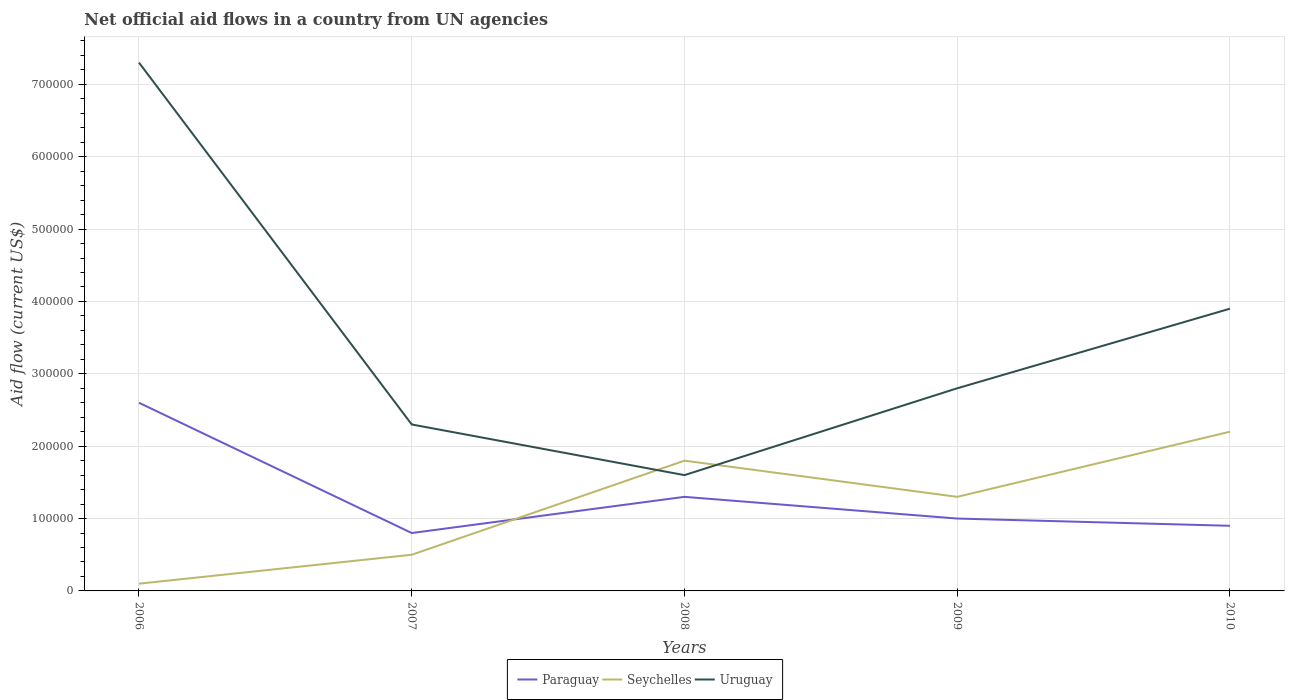Does the line corresponding to Paraguay intersect with the line corresponding to Uruguay?
Offer a very short reply. No. Across all years, what is the maximum net official aid flow in Seychelles?
Ensure brevity in your answer.  10000. What is the total net official aid flow in Seychelles in the graph?
Your response must be concise. 5.00e+04. What is the difference between the highest and the second highest net official aid flow in Uruguay?
Offer a very short reply. 5.70e+05. What is the difference between the highest and the lowest net official aid flow in Uruguay?
Give a very brief answer. 2. Is the net official aid flow in Paraguay strictly greater than the net official aid flow in Uruguay over the years?
Offer a very short reply. Yes. Are the values on the major ticks of Y-axis written in scientific E-notation?
Offer a terse response. No. What is the title of the graph?
Your answer should be compact. Net official aid flows in a country from UN agencies. What is the label or title of the X-axis?
Ensure brevity in your answer.  Years. What is the label or title of the Y-axis?
Your answer should be very brief. Aid flow (current US$). What is the Aid flow (current US$) in Paraguay in 2006?
Your answer should be very brief. 2.60e+05. What is the Aid flow (current US$) of Uruguay in 2006?
Offer a terse response. 7.30e+05. What is the Aid flow (current US$) in Paraguay in 2007?
Provide a short and direct response. 8.00e+04. What is the Aid flow (current US$) in Uruguay in 2007?
Your answer should be compact. 2.30e+05. What is the Aid flow (current US$) of Uruguay in 2008?
Offer a terse response. 1.60e+05. What is the Aid flow (current US$) in Uruguay in 2009?
Make the answer very short. 2.80e+05. What is the Aid flow (current US$) in Paraguay in 2010?
Your response must be concise. 9.00e+04. What is the Aid flow (current US$) of Uruguay in 2010?
Make the answer very short. 3.90e+05. Across all years, what is the maximum Aid flow (current US$) of Paraguay?
Your answer should be compact. 2.60e+05. Across all years, what is the maximum Aid flow (current US$) of Uruguay?
Provide a succinct answer. 7.30e+05. What is the total Aid flow (current US$) in Paraguay in the graph?
Ensure brevity in your answer.  6.60e+05. What is the total Aid flow (current US$) in Seychelles in the graph?
Give a very brief answer. 5.90e+05. What is the total Aid flow (current US$) in Uruguay in the graph?
Your answer should be compact. 1.79e+06. What is the difference between the Aid flow (current US$) in Paraguay in 2006 and that in 2007?
Provide a short and direct response. 1.80e+05. What is the difference between the Aid flow (current US$) of Seychelles in 2006 and that in 2007?
Give a very brief answer. -4.00e+04. What is the difference between the Aid flow (current US$) of Uruguay in 2006 and that in 2007?
Provide a succinct answer. 5.00e+05. What is the difference between the Aid flow (current US$) in Uruguay in 2006 and that in 2008?
Your response must be concise. 5.70e+05. What is the difference between the Aid flow (current US$) in Seychelles in 2006 and that in 2009?
Your answer should be compact. -1.20e+05. What is the difference between the Aid flow (current US$) of Uruguay in 2006 and that in 2009?
Keep it short and to the point. 4.50e+05. What is the difference between the Aid flow (current US$) of Seychelles in 2006 and that in 2010?
Keep it short and to the point. -2.10e+05. What is the difference between the Aid flow (current US$) of Uruguay in 2006 and that in 2010?
Provide a succinct answer. 3.40e+05. What is the difference between the Aid flow (current US$) in Seychelles in 2007 and that in 2008?
Your answer should be very brief. -1.30e+05. What is the difference between the Aid flow (current US$) in Uruguay in 2007 and that in 2008?
Offer a very short reply. 7.00e+04. What is the difference between the Aid flow (current US$) of Paraguay in 2007 and that in 2009?
Provide a succinct answer. -2.00e+04. What is the difference between the Aid flow (current US$) in Uruguay in 2007 and that in 2009?
Make the answer very short. -5.00e+04. What is the difference between the Aid flow (current US$) of Paraguay in 2007 and that in 2010?
Offer a terse response. -10000. What is the difference between the Aid flow (current US$) in Seychelles in 2008 and that in 2010?
Give a very brief answer. -4.00e+04. What is the difference between the Aid flow (current US$) of Paraguay in 2009 and that in 2010?
Provide a short and direct response. 10000. What is the difference between the Aid flow (current US$) of Seychelles in 2009 and that in 2010?
Ensure brevity in your answer.  -9.00e+04. What is the difference between the Aid flow (current US$) of Paraguay in 2006 and the Aid flow (current US$) of Uruguay in 2007?
Provide a succinct answer. 3.00e+04. What is the difference between the Aid flow (current US$) in Seychelles in 2006 and the Aid flow (current US$) in Uruguay in 2007?
Offer a very short reply. -2.20e+05. What is the difference between the Aid flow (current US$) of Paraguay in 2006 and the Aid flow (current US$) of Seychelles in 2008?
Ensure brevity in your answer.  8.00e+04. What is the difference between the Aid flow (current US$) of Paraguay in 2006 and the Aid flow (current US$) of Uruguay in 2008?
Provide a short and direct response. 1.00e+05. What is the difference between the Aid flow (current US$) in Seychelles in 2006 and the Aid flow (current US$) in Uruguay in 2008?
Make the answer very short. -1.50e+05. What is the difference between the Aid flow (current US$) in Paraguay in 2006 and the Aid flow (current US$) in Uruguay in 2009?
Make the answer very short. -2.00e+04. What is the difference between the Aid flow (current US$) of Seychelles in 2006 and the Aid flow (current US$) of Uruguay in 2009?
Your response must be concise. -2.70e+05. What is the difference between the Aid flow (current US$) of Paraguay in 2006 and the Aid flow (current US$) of Uruguay in 2010?
Provide a succinct answer. -1.30e+05. What is the difference between the Aid flow (current US$) in Seychelles in 2006 and the Aid flow (current US$) in Uruguay in 2010?
Offer a terse response. -3.80e+05. What is the difference between the Aid flow (current US$) in Seychelles in 2007 and the Aid flow (current US$) in Uruguay in 2008?
Offer a terse response. -1.10e+05. What is the difference between the Aid flow (current US$) of Paraguay in 2007 and the Aid flow (current US$) of Seychelles in 2009?
Make the answer very short. -5.00e+04. What is the difference between the Aid flow (current US$) of Paraguay in 2007 and the Aid flow (current US$) of Uruguay in 2009?
Provide a short and direct response. -2.00e+05. What is the difference between the Aid flow (current US$) in Paraguay in 2007 and the Aid flow (current US$) in Uruguay in 2010?
Offer a terse response. -3.10e+05. What is the difference between the Aid flow (current US$) in Paraguay in 2008 and the Aid flow (current US$) in Seychelles in 2009?
Your answer should be compact. 0. What is the difference between the Aid flow (current US$) of Paraguay in 2008 and the Aid flow (current US$) of Uruguay in 2009?
Your response must be concise. -1.50e+05. What is the difference between the Aid flow (current US$) of Paraguay in 2008 and the Aid flow (current US$) of Seychelles in 2010?
Your response must be concise. -9.00e+04. What is the difference between the Aid flow (current US$) of Seychelles in 2008 and the Aid flow (current US$) of Uruguay in 2010?
Make the answer very short. -2.10e+05. What is the average Aid flow (current US$) of Paraguay per year?
Your answer should be compact. 1.32e+05. What is the average Aid flow (current US$) in Seychelles per year?
Make the answer very short. 1.18e+05. What is the average Aid flow (current US$) in Uruguay per year?
Give a very brief answer. 3.58e+05. In the year 2006, what is the difference between the Aid flow (current US$) of Paraguay and Aid flow (current US$) of Uruguay?
Offer a terse response. -4.70e+05. In the year 2006, what is the difference between the Aid flow (current US$) of Seychelles and Aid flow (current US$) of Uruguay?
Give a very brief answer. -7.20e+05. In the year 2007, what is the difference between the Aid flow (current US$) of Paraguay and Aid flow (current US$) of Uruguay?
Provide a succinct answer. -1.50e+05. In the year 2007, what is the difference between the Aid flow (current US$) of Seychelles and Aid flow (current US$) of Uruguay?
Make the answer very short. -1.80e+05. In the year 2008, what is the difference between the Aid flow (current US$) of Seychelles and Aid flow (current US$) of Uruguay?
Make the answer very short. 2.00e+04. In the year 2009, what is the difference between the Aid flow (current US$) of Paraguay and Aid flow (current US$) of Seychelles?
Your response must be concise. -3.00e+04. In the year 2009, what is the difference between the Aid flow (current US$) in Paraguay and Aid flow (current US$) in Uruguay?
Keep it short and to the point. -1.80e+05. In the year 2009, what is the difference between the Aid flow (current US$) in Seychelles and Aid flow (current US$) in Uruguay?
Give a very brief answer. -1.50e+05. In the year 2010, what is the difference between the Aid flow (current US$) of Paraguay and Aid flow (current US$) of Seychelles?
Your answer should be very brief. -1.30e+05. What is the ratio of the Aid flow (current US$) of Paraguay in 2006 to that in 2007?
Give a very brief answer. 3.25. What is the ratio of the Aid flow (current US$) in Seychelles in 2006 to that in 2007?
Offer a terse response. 0.2. What is the ratio of the Aid flow (current US$) of Uruguay in 2006 to that in 2007?
Your answer should be compact. 3.17. What is the ratio of the Aid flow (current US$) of Seychelles in 2006 to that in 2008?
Offer a very short reply. 0.06. What is the ratio of the Aid flow (current US$) of Uruguay in 2006 to that in 2008?
Give a very brief answer. 4.56. What is the ratio of the Aid flow (current US$) in Seychelles in 2006 to that in 2009?
Offer a terse response. 0.08. What is the ratio of the Aid flow (current US$) in Uruguay in 2006 to that in 2009?
Offer a very short reply. 2.61. What is the ratio of the Aid flow (current US$) in Paraguay in 2006 to that in 2010?
Your answer should be very brief. 2.89. What is the ratio of the Aid flow (current US$) in Seychelles in 2006 to that in 2010?
Your response must be concise. 0.05. What is the ratio of the Aid flow (current US$) of Uruguay in 2006 to that in 2010?
Offer a very short reply. 1.87. What is the ratio of the Aid flow (current US$) of Paraguay in 2007 to that in 2008?
Provide a succinct answer. 0.62. What is the ratio of the Aid flow (current US$) in Seychelles in 2007 to that in 2008?
Offer a terse response. 0.28. What is the ratio of the Aid flow (current US$) of Uruguay in 2007 to that in 2008?
Ensure brevity in your answer.  1.44. What is the ratio of the Aid flow (current US$) of Seychelles in 2007 to that in 2009?
Provide a succinct answer. 0.38. What is the ratio of the Aid flow (current US$) in Uruguay in 2007 to that in 2009?
Your answer should be compact. 0.82. What is the ratio of the Aid flow (current US$) in Seychelles in 2007 to that in 2010?
Your response must be concise. 0.23. What is the ratio of the Aid flow (current US$) of Uruguay in 2007 to that in 2010?
Your response must be concise. 0.59. What is the ratio of the Aid flow (current US$) in Paraguay in 2008 to that in 2009?
Your answer should be very brief. 1.3. What is the ratio of the Aid flow (current US$) in Seychelles in 2008 to that in 2009?
Ensure brevity in your answer.  1.38. What is the ratio of the Aid flow (current US$) in Paraguay in 2008 to that in 2010?
Make the answer very short. 1.44. What is the ratio of the Aid flow (current US$) of Seychelles in 2008 to that in 2010?
Ensure brevity in your answer.  0.82. What is the ratio of the Aid flow (current US$) in Uruguay in 2008 to that in 2010?
Your response must be concise. 0.41. What is the ratio of the Aid flow (current US$) in Seychelles in 2009 to that in 2010?
Your answer should be very brief. 0.59. What is the ratio of the Aid flow (current US$) in Uruguay in 2009 to that in 2010?
Your response must be concise. 0.72. What is the difference between the highest and the second highest Aid flow (current US$) of Paraguay?
Provide a succinct answer. 1.30e+05. What is the difference between the highest and the lowest Aid flow (current US$) in Paraguay?
Ensure brevity in your answer.  1.80e+05. What is the difference between the highest and the lowest Aid flow (current US$) of Uruguay?
Your answer should be compact. 5.70e+05. 